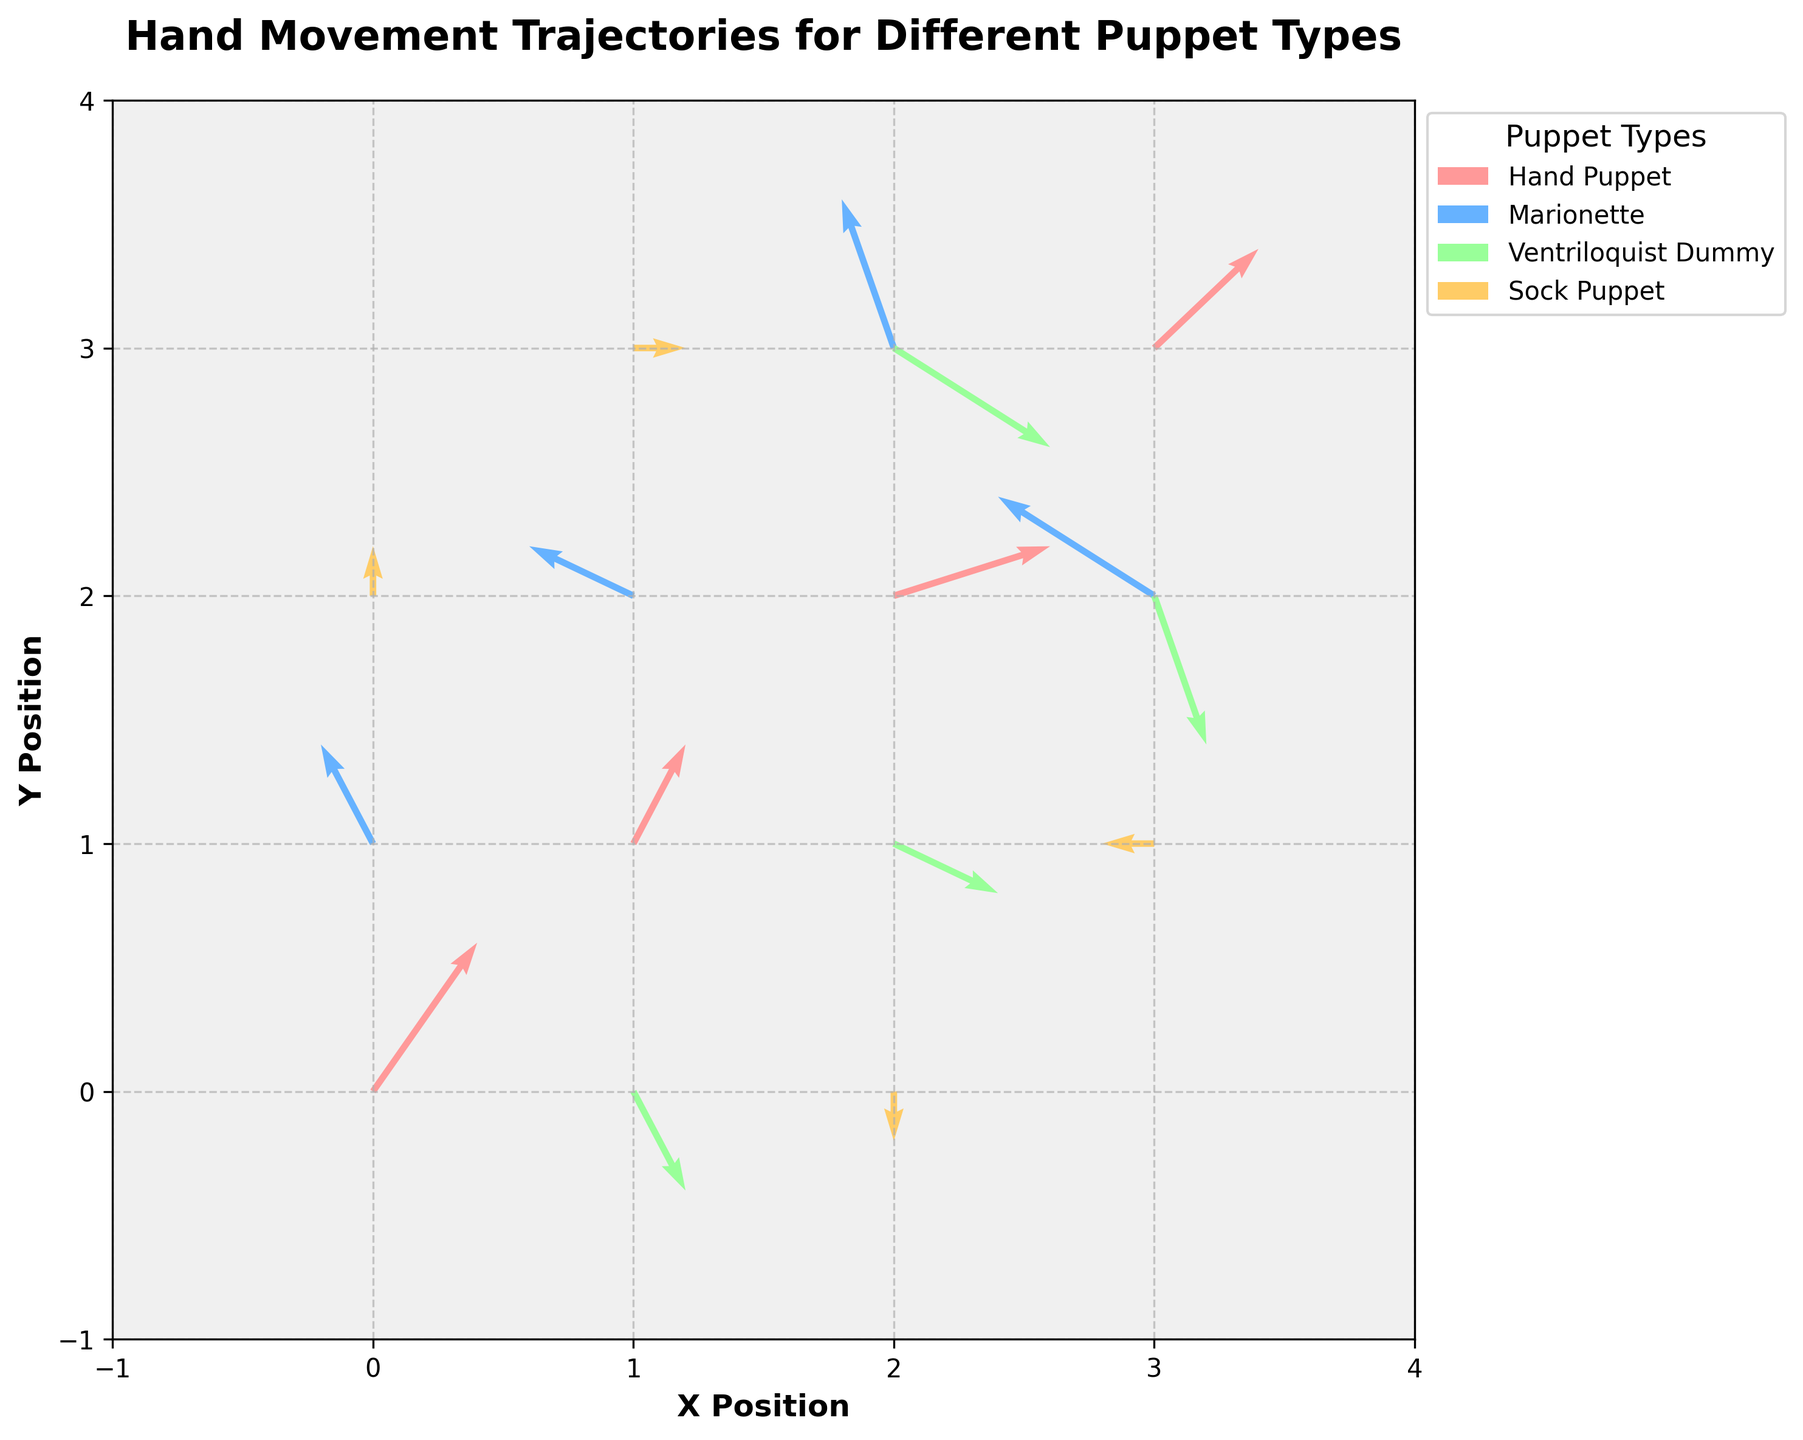What's the title of the figure? The title of the figure is located at the top and it reads "Hand Movement Trajectories for Different Puppet Types".
Answer: Hand Movement Trajectories for Different Puppet Types How many puppet types are displayed in the figure? The legend in the figure shows distinct entries for each puppet type, which are labeled as Hand Puppet, Marionette, Ventriloquist Dummy, and Sock Puppet.
Answer: 4 Which puppet type has the trajectories with the most positive x and y direction? By observing the individual vectors and their directions, the Ventriloquist Dummy has trajectories mostly in the positive x and negative y directions, pointing downwards with both positive x and negative y components.
Answer: Ventriloquist Dummy What color represents the Hand Puppet trajectories? The Hand Puppet trajectories are represented in the color pink, as indicated by the corresponding entry in the legend.
Answer: Pink What's the resultant vector length for the Hand Puppet trajectory starting at (0,0)? The resultant vector length can be calculated using the formula sqrt(u^2 + v^2). For the Hand Puppet starting at (0,0) with u=2 and v=3, it's sqrt(2^2 + 3^2) = sqrt(4 + 9) = sqrt(13) ≈ 3.61.
Answer: 3.61 Which puppet type has the only vector that points in the negative x-direction at starting point (3,1)? From the figure, the vector starting at (3,1) and moving in the negative x-direction belongs to the Sock Puppet, as indicated by its representation in light orange color.
Answer: Sock Puppet What is the x and y magnitude of the largest vector for the Marionette puppet type? For the Marionette puppet type, the largest vector magnitude can be identified visually. The vector starting at (2,3) shows the largest movement, with component magnitudes u=-1 and v=3.
Answer: u=-1, v=3 How many vectors start from the position (2,3)? Observing the vector origins, there are two vectors that start from the position (2,3); one from the Marionette puppet type and one from the Ventriloquist Dummy.
Answer: 2 What is the average length of the vectors for the Sock Puppet type? First, calculate the length of each vector: (0,1): len=1; (1,3): len=1; (2,0): len=1; (3,1): len=1. Now, average these lengths: (1+1+1+1)/4 = 1.
Answer: 1 